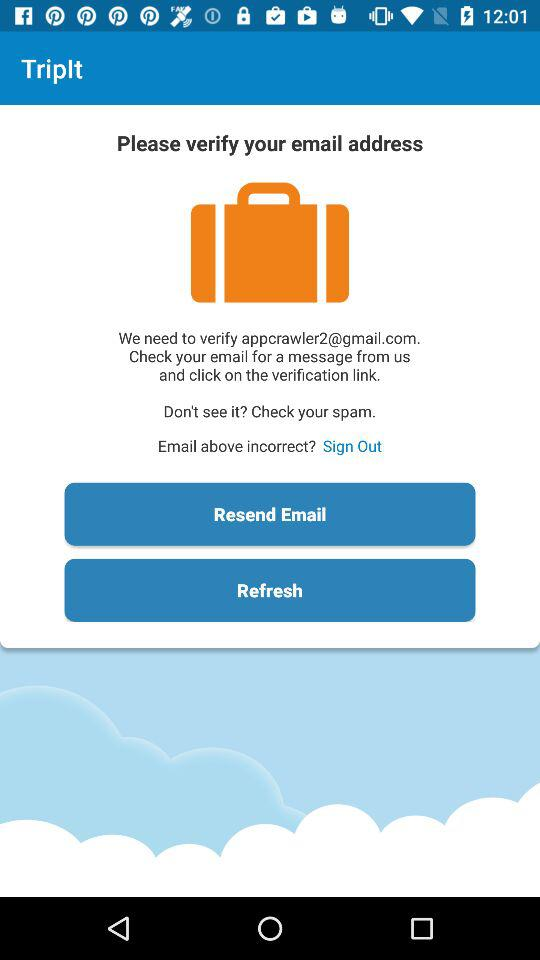What is the email address? The email address is appcrawler2@gmail.com. 